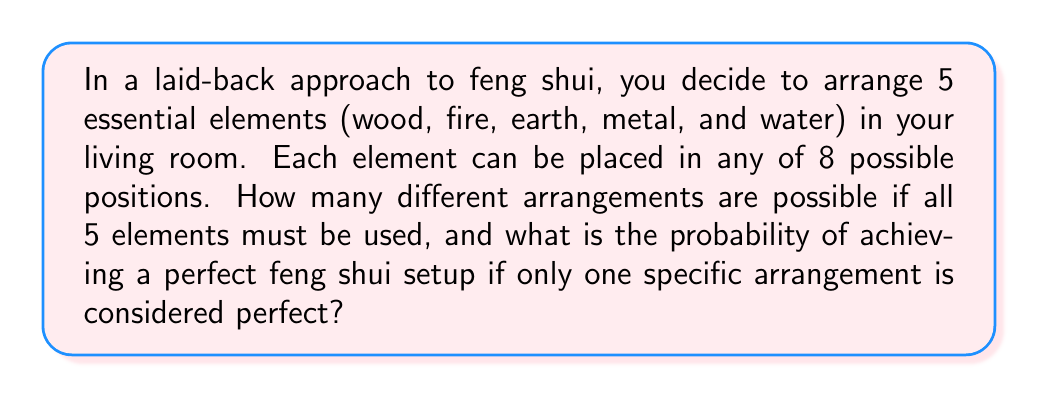Can you solve this math problem? Let's approach this step-by-step:

1) First, we need to calculate the total number of possible arrangements. This is a permutation problem with repetition allowed.

2) We have 8 positions and 5 elements to place. The order matters, and we can use each position only once. This scenario is described by the permutation formula:

   $$P(n,r) = n^r$$

   Where $n$ is the number of positions (8) and $r$ is the number of elements to place (5).

3) Plugging in our values:

   $$P(8,5) = 8^5 = 32,768$$

4) This means there are 32,768 possible arrangements of the 5 elements in the 8 positions.

5) Now, we're told that only one specific arrangement is considered perfect feng shui.

6) The probability of an event is calculated by:

   $$P(\text{event}) = \frac{\text{number of favorable outcomes}}{\text{total number of possible outcomes}}$$

7) In this case:
   - Favorable outcome: 1 (only one perfect arrangement)
   - Total possible outcomes: 32,768

8) Therefore, the probability is:

   $$P(\text{perfect feng shui}) = \frac{1}{32,768} = 0.0000305176$$
Answer: The probability of achieving a perfect feng shui setup is $\frac{1}{32,768}$ or approximately $0.0000305176$. 